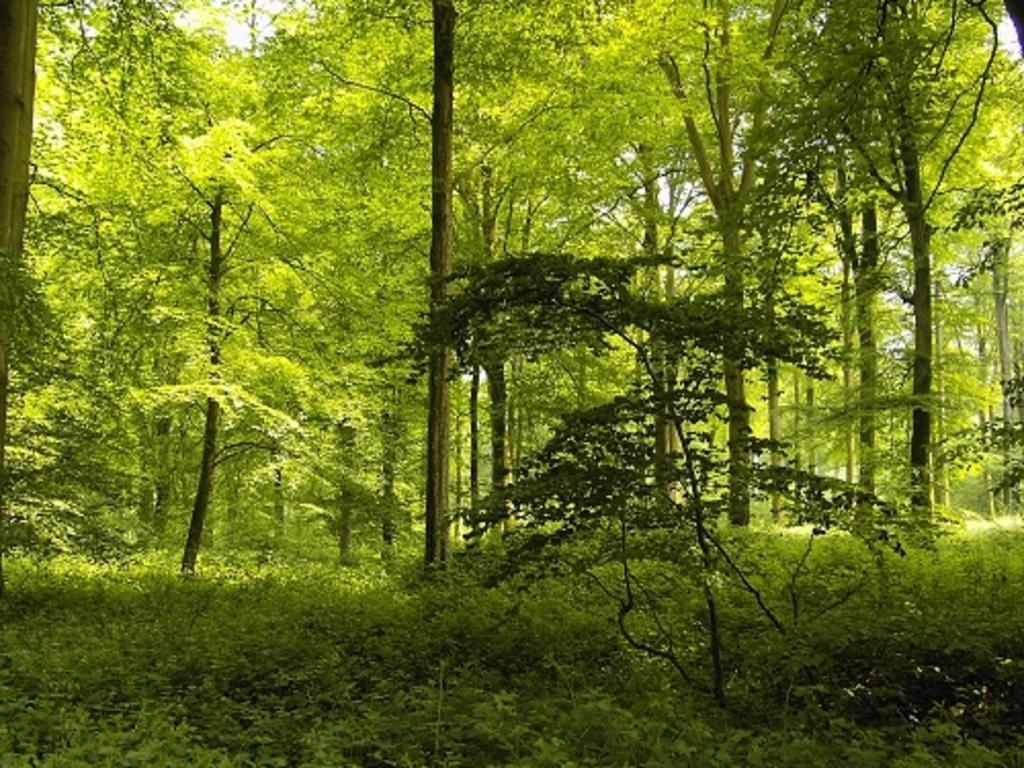Please provide a concise description of this image. The image is taken in a forest or in a park. In the foreground of the picture there are plants and trees. In the background there are trees. 